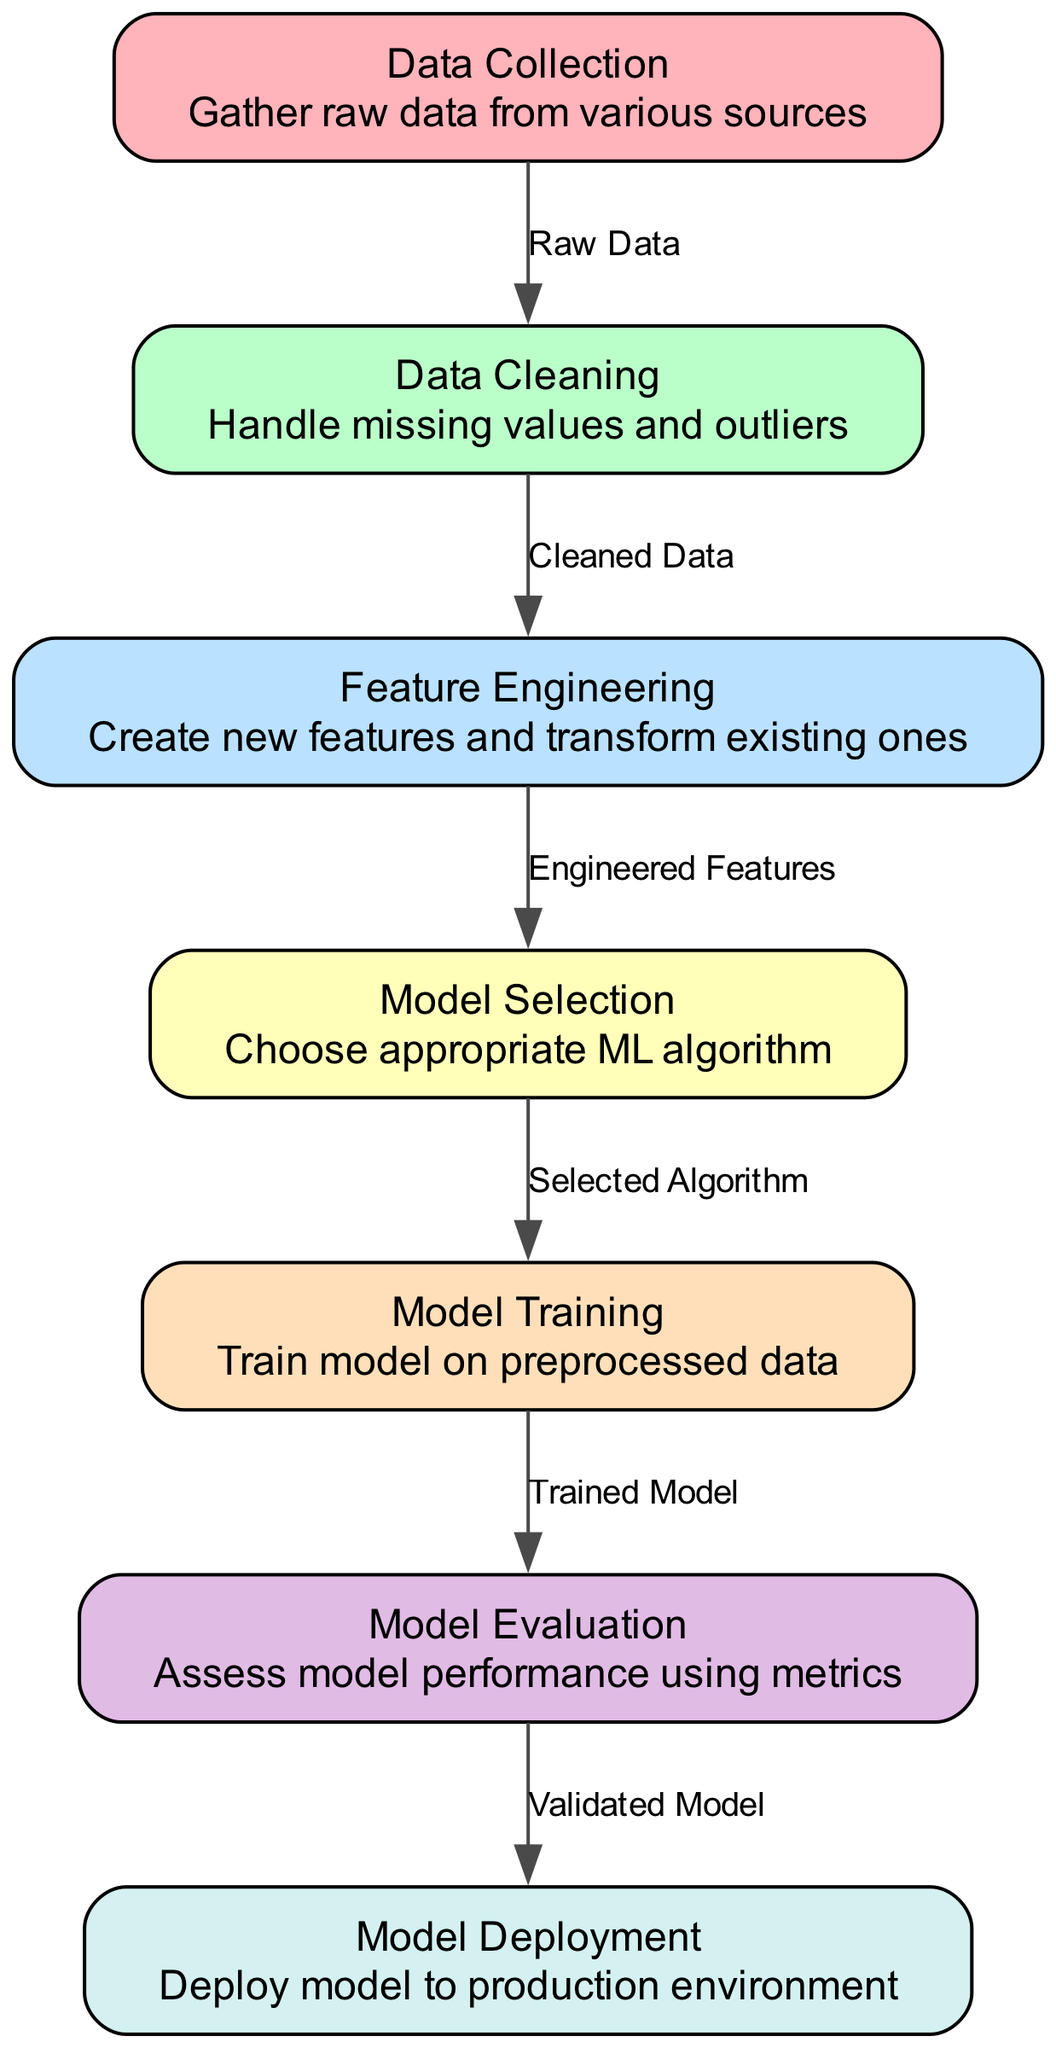What is the first stage of the machine learning pipeline? The diagram shows the first node labeled "Data Collection," which indicates it is the initial stage where raw data is gathered from various sources.
Answer: Data Collection How many nodes are there in the diagram? Counting the nodes listed in the diagram reveals there are a total of seven nodes representing different stages of the machine learning pipeline.
Answer: Seven What type of data is transferred from Data Cleaning to Feature Engineering? The transition from Data Cleaning to Feature Engineering is labeled as "Cleaned Data," indicating that processed data is used in the next stage.
Answer: Cleaned Data Which node assesses the model performance? The diagram shows that the node called "Model Evaluation" is specifically designated to evaluate the performance of the model using various metrics.
Answer: Model Evaluation What is the last step in the machine learning pipeline? The last node in the diagram is "Model Deployment," which signifies that the final stage involves deploying the model to a production environment.
Answer: Model Deployment What flows into the Model Training stage? According to the diagram, the edge from the "Model Selection" node to the "Model Training" node is labeled with "Selected Algorithm," indicating that the chosen algorithm is the input for training.
Answer: Selected Algorithm Which two stages are directly connected to Model Evaluation? The model transitions from "Model Training" to "Model Evaluation" after training, and then it moves to "Model Deployment" after evaluation; therefore, the two directly connected stages are Model Training and Model Deployment.
Answer: Model Training, Model Deployment What role does Feature Engineering play in the pipeline? Feature Engineering is depicted in the diagram as the stage where new features are created and existing ones are transformed, making it crucial for model performance.
Answer: Create new features and transform existing ones What is the relationship between Model Evaluation and Model Deployment? The edge from "Model Evaluation" to "Model Deployment" is labeled "Validated Model," indicating that the model must pass evaluation to proceed to deployment.
Answer: Validated Model 